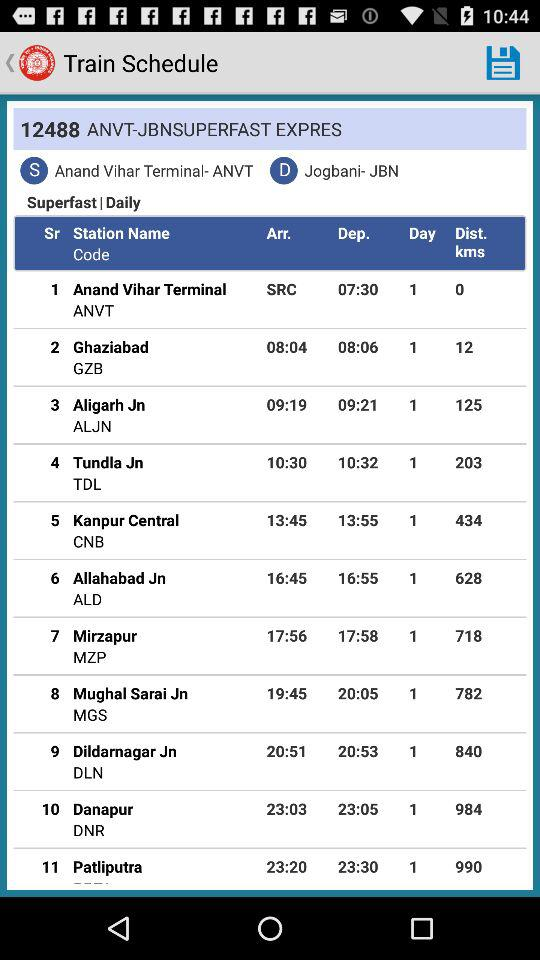What is the departure time of the train from Anand Vihar Terminal? The departure time of the train is 07:30. 